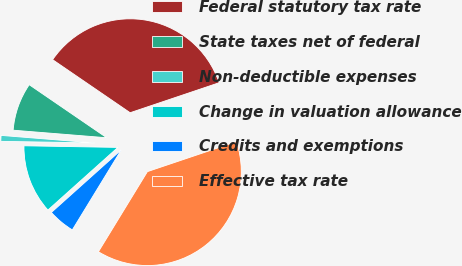Convert chart. <chart><loc_0><loc_0><loc_500><loc_500><pie_chart><fcel>Federal statutory tax rate<fcel>State taxes net of federal<fcel>Non-deductible expenses<fcel>Change in valuation allowance<fcel>Credits and exemptions<fcel>Effective tax rate<nl><fcel>35.28%<fcel>8.27%<fcel>1.01%<fcel>11.9%<fcel>4.64%<fcel>38.91%<nl></chart> 